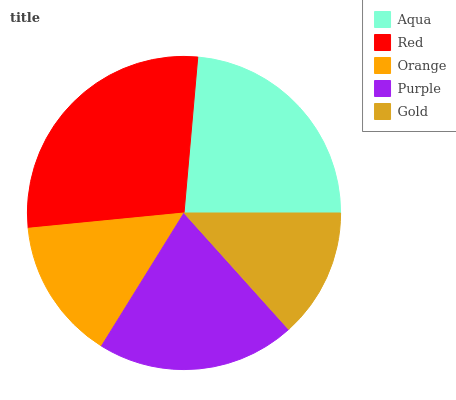Is Gold the minimum?
Answer yes or no. Yes. Is Red the maximum?
Answer yes or no. Yes. Is Orange the minimum?
Answer yes or no. No. Is Orange the maximum?
Answer yes or no. No. Is Red greater than Orange?
Answer yes or no. Yes. Is Orange less than Red?
Answer yes or no. Yes. Is Orange greater than Red?
Answer yes or no. No. Is Red less than Orange?
Answer yes or no. No. Is Purple the high median?
Answer yes or no. Yes. Is Purple the low median?
Answer yes or no. Yes. Is Gold the high median?
Answer yes or no. No. Is Red the low median?
Answer yes or no. No. 